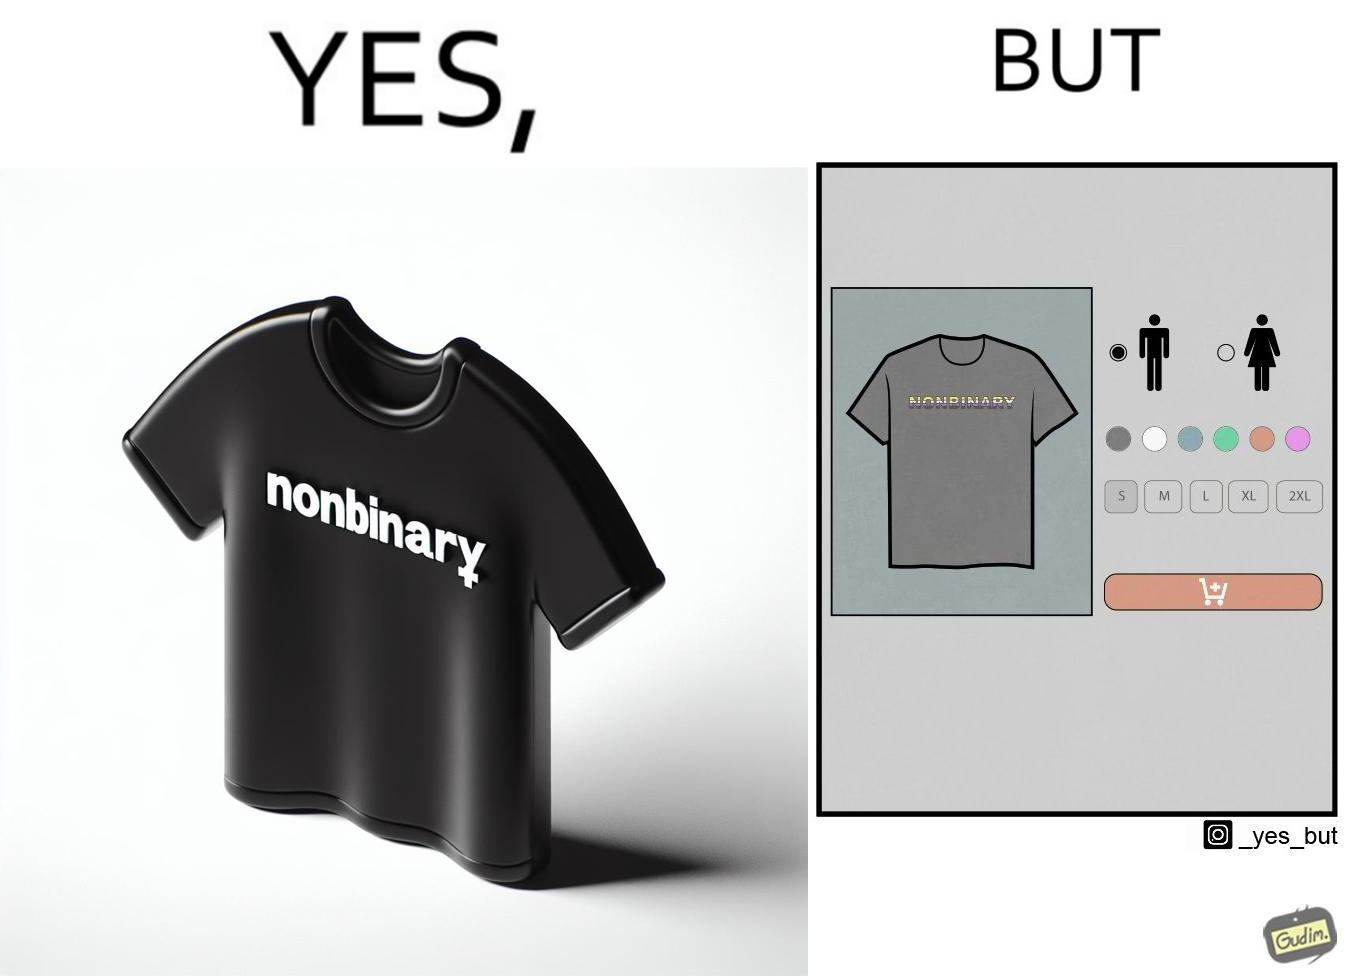Compare the left and right sides of this image. In the left part of the image: t-shirt with "NONBINARY" written on it. In the right part of the image: t-shirt with "NONBINARY" written on it, with several customizable options for color and 2 gender options on the right 